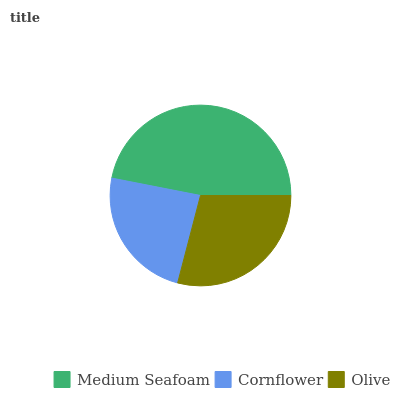Is Cornflower the minimum?
Answer yes or no. Yes. Is Medium Seafoam the maximum?
Answer yes or no. Yes. Is Olive the minimum?
Answer yes or no. No. Is Olive the maximum?
Answer yes or no. No. Is Olive greater than Cornflower?
Answer yes or no. Yes. Is Cornflower less than Olive?
Answer yes or no. Yes. Is Cornflower greater than Olive?
Answer yes or no. No. Is Olive less than Cornflower?
Answer yes or no. No. Is Olive the high median?
Answer yes or no. Yes. Is Olive the low median?
Answer yes or no. Yes. Is Cornflower the high median?
Answer yes or no. No. Is Medium Seafoam the low median?
Answer yes or no. No. 